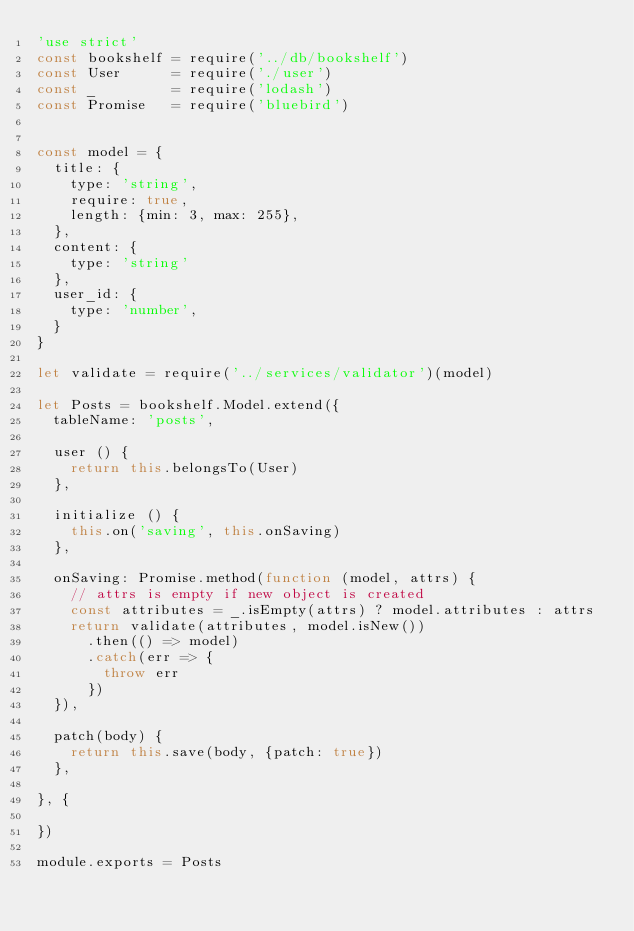<code> <loc_0><loc_0><loc_500><loc_500><_JavaScript_>'use strict'
const bookshelf = require('../db/bookshelf')
const User      = require('./user')
const _         = require('lodash')
const Promise   = require('bluebird')


const model = {
  title: {
    type: 'string',
    require: true,
    length: {min: 3, max: 255},
  },
  content: {
    type: 'string'
  },
  user_id: {
    type: 'number',
  }
}

let validate = require('../services/validator')(model)

let Posts = bookshelf.Model.extend({
  tableName: 'posts',

  user () {
    return this.belongsTo(User)
  },

  initialize () {
    this.on('saving', this.onSaving)
  },

  onSaving: Promise.method(function (model, attrs) {
    // attrs is empty if new object is created
    const attributes = _.isEmpty(attrs) ? model.attributes : attrs
    return validate(attributes, model.isNew())
      .then(() => model)
      .catch(err => {
        throw err
      })
  }),

  patch(body) {
    return this.save(body, {patch: true})
  },

}, {

})

module.exports = Posts
</code> 